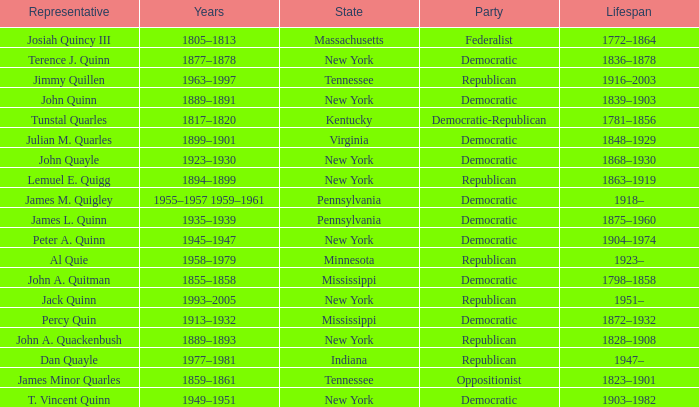Which state does Jimmy Quillen represent? Tennessee. 